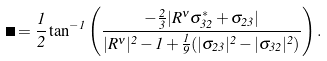Convert formula to latex. <formula><loc_0><loc_0><loc_500><loc_500>\Theta = { \frac { 1 } { 2 } } \tan ^ { - 1 } \left ( { \frac { - { \frac { 2 } { 3 } } | R ^ { \nu } \sigma _ { 3 2 } ^ { * } + \sigma _ { 2 3 } | } { | R ^ { \nu } | ^ { 2 } - 1 + { \frac { 1 } { 9 } } ( | \sigma _ { 2 3 } | ^ { 2 } - | \sigma _ { 3 2 } | ^ { 2 } ) } } \right ) .</formula> 